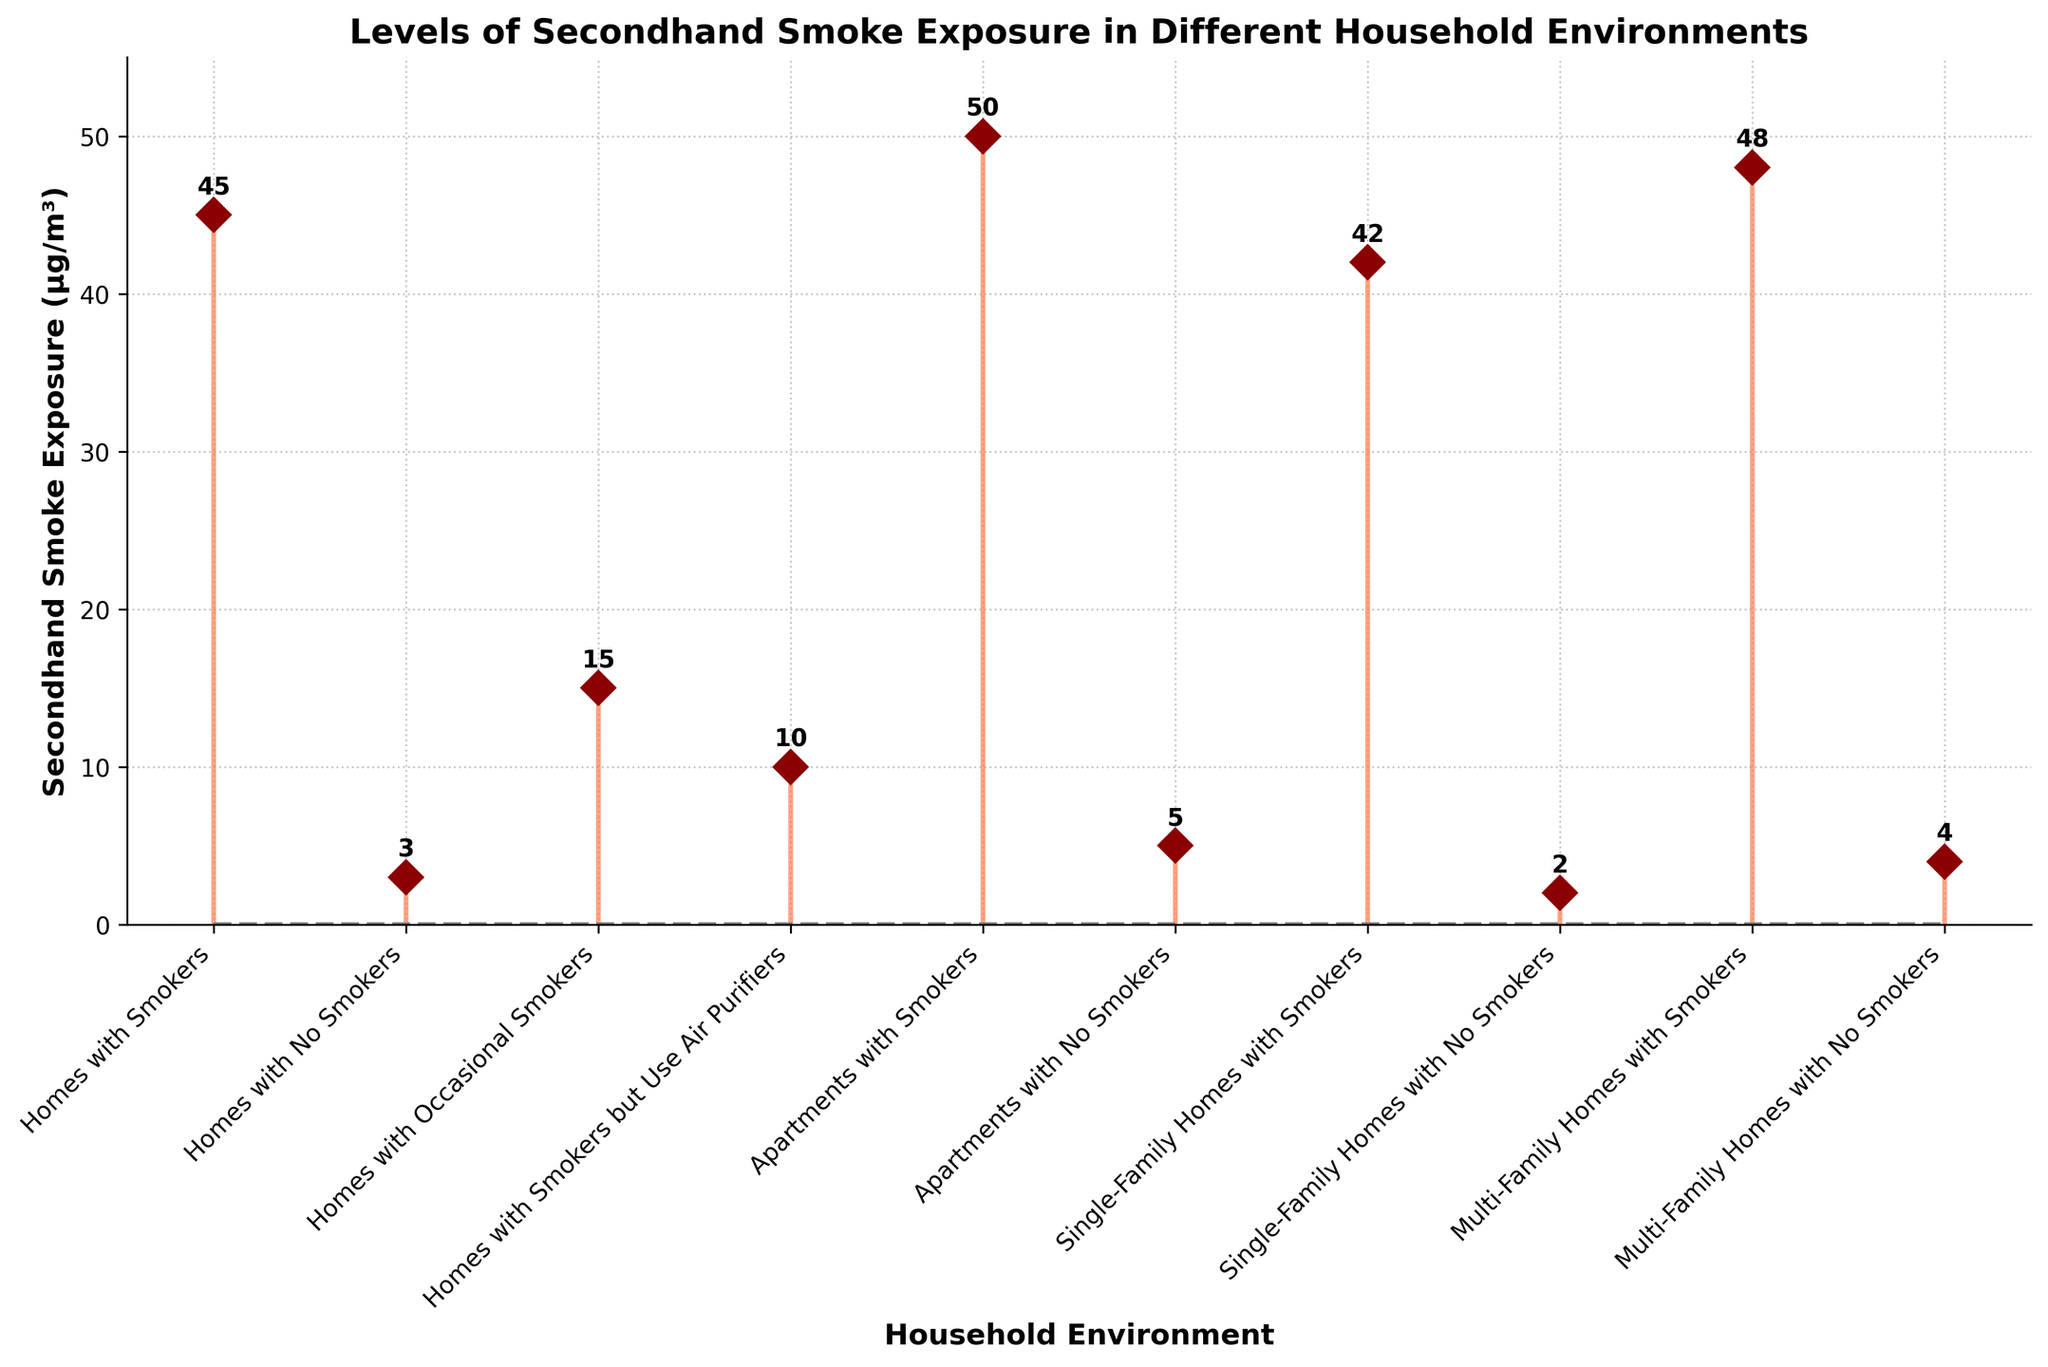What's the title of the figure? The title is usually at the top of the figure. In this case, it is displayed in bold font. The text reads "Levels of Secondhand Smoke Exposure in Different Household Environments".
Answer: Levels of Secondhand Smoke Exposure in Different Household Environments How many different household environments are shown in the figure? Count the number of unique entries listed on the x-axis. There are 10 different household environments displayed in the figure.
Answer: 10 Which household environment has the highest level of secondhand smoke exposure? Look for the marker with the highest value on the y-axis. In this case, "Apartments with Smokers" has the highest value of 50 µg/m³.
Answer: Apartments with Smokers What is the difference in secondhand smoke exposure between "Homes with Smokers" and "Homes with No Smokers"? Subtract the value for "Homes with No Smokers" from the value for "Homes with Smokers" (45 - 3 = 42 µg/m³).
Answer: 42 µg/m³ Which environments have an exposure level of 5 µg/m³ or less? Look for the markers that are at or below the 5 µg/m³ level on the y-axis. These are "Homes with No Smokers" (3 µg/m³), "Apartments with No Smokers" (5 µg/m³), and "Single-Family Homes with No Smokers" (2 µg/m³).
Answer: Homes with No Smokers, Apartments with No Smokers, Single-Family Homes with No Smokers Are there any environments where the secondhand smoke exposure is exactly 10 µg/m³? Check the markers on the y-axis for a value of 10 µg/m³. "Homes with Smokers but Use Air Purifiers" has a value of 10 µg/m³.
Answer: Homes with Smokers but Use Air Purifiers What is the average secondhand smoke exposure in homes where there are smokers? Sum the exposure levels for "Homes with Smokers" (45), "Homes with Occasional Smokers" (15), and "Homes with Smokers but Use Air Purifiers" (10), and divide by 3. The sum is 70, so the average is 70 / 3 ≈ 23.3 µg/m³.
Answer: 23.3 µg/m³ Which environment has a higher secondhand smoke exposure: "Multi-Family Homes with Smokers" or "Single-Family Homes with Smokers"? Compare the values for "Multi-Family Homes with Smokers" (48 µg/m³) and "Single-Family Homes with Smokers" (42 µg/m³). "Multi-Family Homes with Smokers" has a higher exposure.
Answer: Multi-Family Homes with Smokers What is the range of secondhand smoke exposure levels among the household environments? Subtract the smallest value from the largest value. The largest is 50 µg/m³ (Apartments with Smokers) and the smallest is 2 µg/m³ (Single-Family Homes with No Smokers), so the range is 50 - 2 = 48 µg/m³.
Answer: 48 µg/m³ 